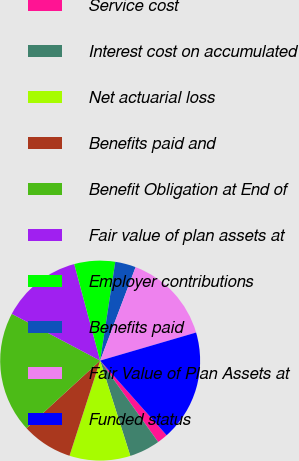Convert chart to OTSL. <chart><loc_0><loc_0><loc_500><loc_500><pie_chart><fcel>Service cost<fcel>Interest cost on accumulated<fcel>Net actuarial loss<fcel>Benefits paid and<fcel>Benefit Obligation at End of<fcel>Fair value of plan assets at<fcel>Employer contributions<fcel>Benefits paid<fcel>Fair Value of Plan Assets at<fcel>Funded status<nl><fcel>1.73%<fcel>4.97%<fcel>9.84%<fcel>8.22%<fcel>19.57%<fcel>13.08%<fcel>6.59%<fcel>3.35%<fcel>14.7%<fcel>17.95%<nl></chart> 